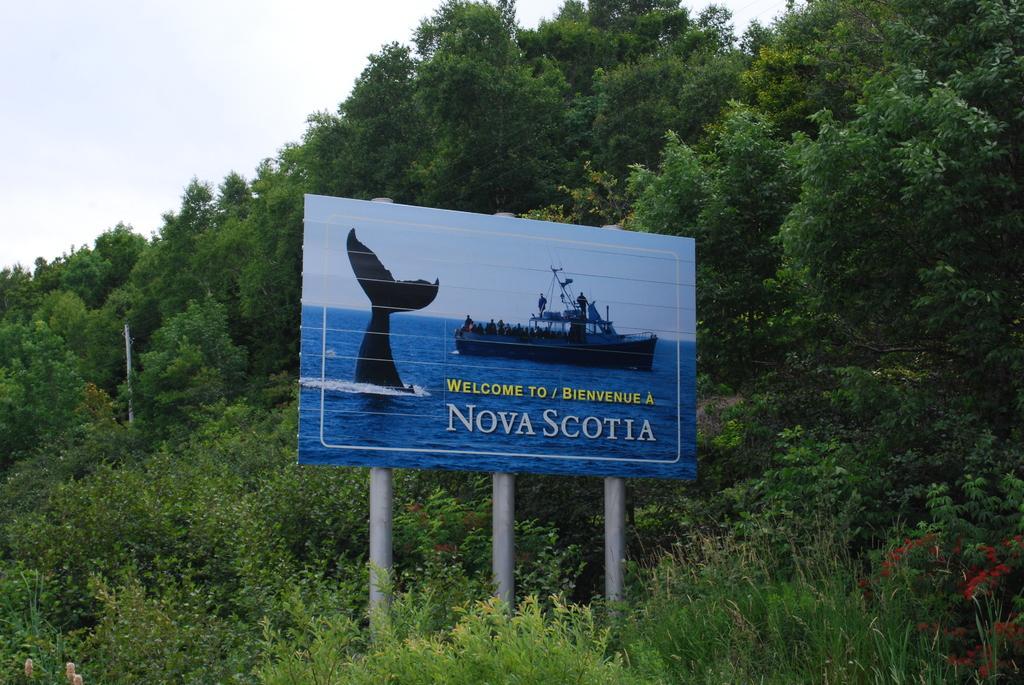How would you summarize this image in a sentence or two? In this image I can see three metal poles and to them I can see a board. I can see few trees which are green in color and in the background I can see the sky. 